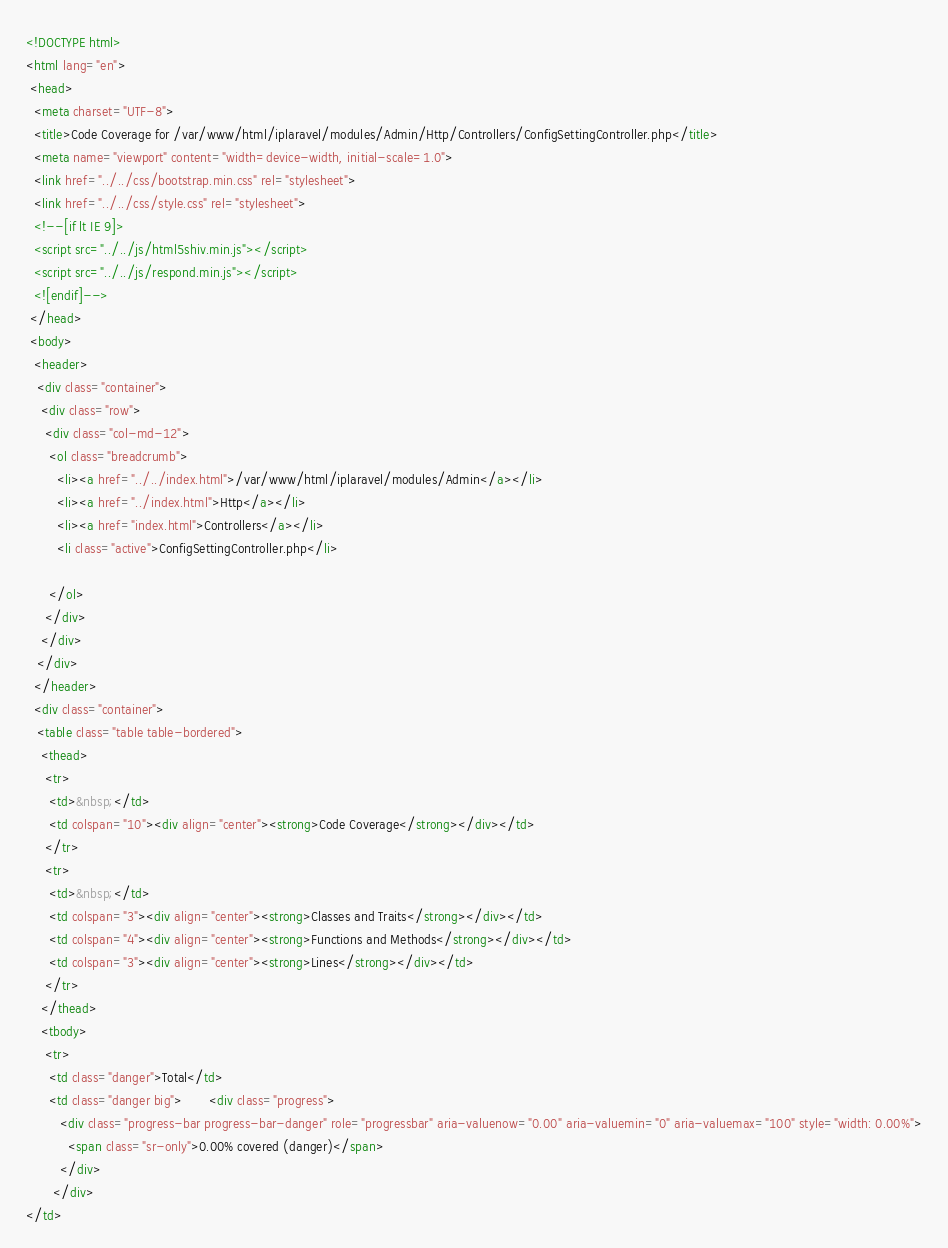Convert code to text. <code><loc_0><loc_0><loc_500><loc_500><_HTML_><!DOCTYPE html>
<html lang="en">
 <head>
  <meta charset="UTF-8">
  <title>Code Coverage for /var/www/html/iplaravel/modules/Admin/Http/Controllers/ConfigSettingController.php</title>
  <meta name="viewport" content="width=device-width, initial-scale=1.0">
  <link href="../../css/bootstrap.min.css" rel="stylesheet">
  <link href="../../css/style.css" rel="stylesheet">
  <!--[if lt IE 9]>
  <script src="../../js/html5shiv.min.js"></script>
  <script src="../../js/respond.min.js"></script>
  <![endif]-->
 </head>
 <body>
  <header>
   <div class="container">
    <div class="row">
     <div class="col-md-12">
      <ol class="breadcrumb">
        <li><a href="../../index.html">/var/www/html/iplaravel/modules/Admin</a></li>
        <li><a href="../index.html">Http</a></li>
        <li><a href="index.html">Controllers</a></li>
        <li class="active">ConfigSettingController.php</li>

      </ol>
     </div>
    </div>
   </div>
  </header>
  <div class="container">
   <table class="table table-bordered">
    <thead>
     <tr>
      <td>&nbsp;</td>
      <td colspan="10"><div align="center"><strong>Code Coverage</strong></div></td>
     </tr>
     <tr>
      <td>&nbsp;</td>
      <td colspan="3"><div align="center"><strong>Classes and Traits</strong></div></td>
      <td colspan="4"><div align="center"><strong>Functions and Methods</strong></div></td>
      <td colspan="3"><div align="center"><strong>Lines</strong></div></td>
     </tr>
    </thead>
    <tbody>
     <tr>
      <td class="danger">Total</td>
      <td class="danger big">       <div class="progress">
         <div class="progress-bar progress-bar-danger" role="progressbar" aria-valuenow="0.00" aria-valuemin="0" aria-valuemax="100" style="width: 0.00%">
           <span class="sr-only">0.00% covered (danger)</span>
         </div>
       </div>
</td></code> 